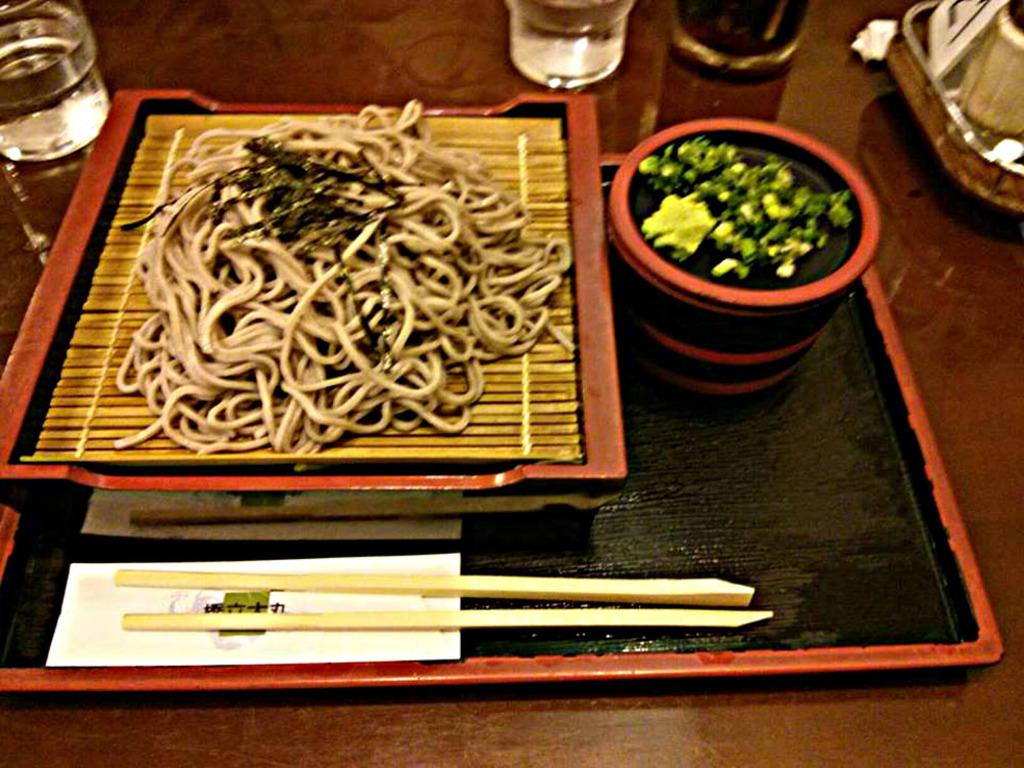What type of food is present in the image? There are noodles in the image. What utensils are used to eat the food in the image? There are chopsticks in the image. What is the food contained in? There is a bowl of food in the image. What might be used for drinking in the image? There are water glasses on the table in the image. What historical event is being commemorated in the image? There is no indication of a historical event being commemorated in the image. 